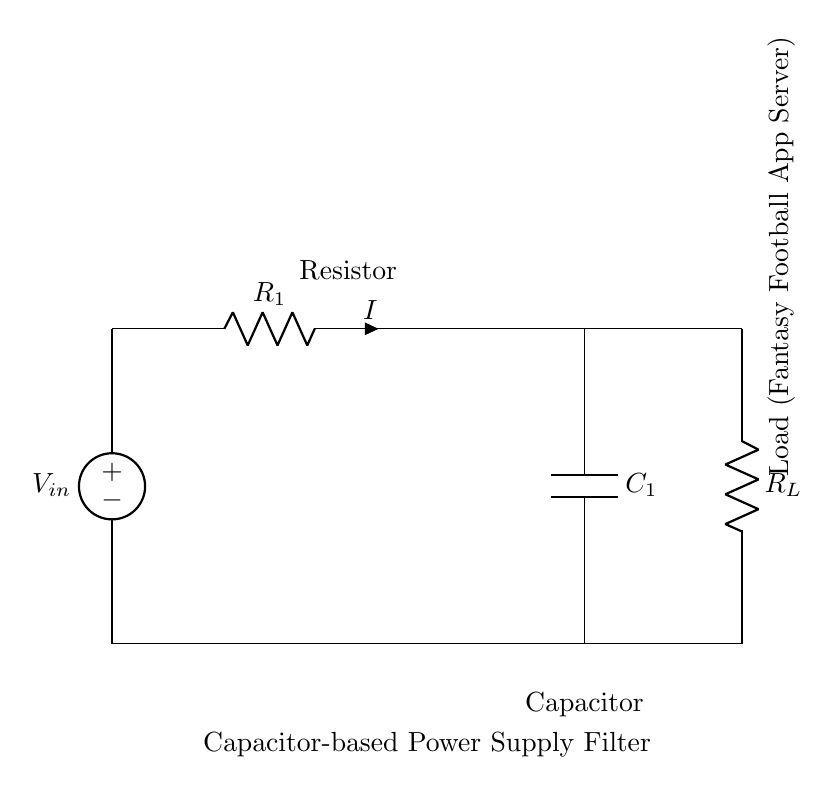What is the value of the load resistor? The load resistor is labeled as R_L in the circuit diagram, but its specific value is not provided. However, it's critical in determining the load on the capacitor-power supply circuit.
Answer: R_L What is the type of filter used in this circuit? The circuit design indicates a capacitor-based power supply filter that smooths out voltage fluctuations. It uses capacitors to filter the output from the power supply.
Answer: Capacitor-based What component stores energy in this circuit? The component that stores energy in this circuit is the capacitor, labeled as C_1. Its main function is to store and release electrical energy as needed, smoothing the output voltage.
Answer: Capacitor What does the voltage source provide? The voltage source, labeled as V_in, provides the input voltage necessary for the circuit to function. It powers the load via the resistor-capacitor arrangement.
Answer: Input voltage How does increasing the capacitor value affect the circuit? Increasing the capacitor value reduces the ripple voltage across the load, leading to a more stable output voltage. A larger capacitor can store more energy, resulting in better filtering performance.
Answer: More stable output What is the purpose of resistor R_1? Resistor R_1 limits the current flow in the circuit and affects the charging rate of the capacitor. It helps to set the time constant for the RC circuit, impacting how quickly the capacitor charges and discharges.
Answer: Limit current 